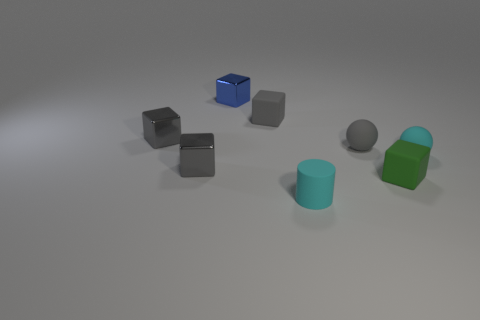Subtract all yellow cylinders. How many gray cubes are left? 3 Subtract all tiny blue blocks. How many blocks are left? 4 Add 1 tiny green matte cubes. How many objects exist? 9 Subtract 1 spheres. How many spheres are left? 1 Add 1 big red rubber balls. How many big red rubber balls exist? 1 Subtract all blue blocks. How many blocks are left? 4 Subtract 1 gray spheres. How many objects are left? 7 Subtract all cubes. How many objects are left? 3 Subtract all yellow balls. Subtract all red cylinders. How many balls are left? 2 Subtract all matte cylinders. Subtract all tiny rubber things. How many objects are left? 2 